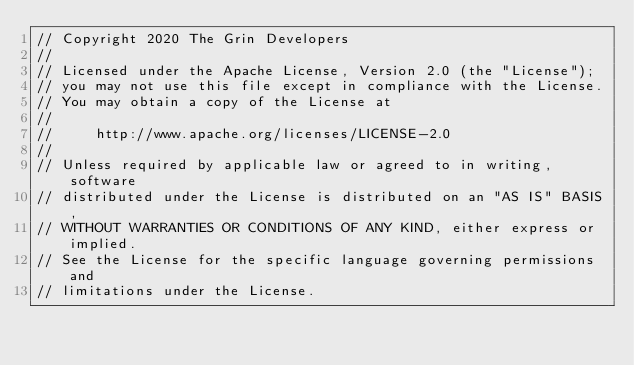<code> <loc_0><loc_0><loc_500><loc_500><_Rust_>// Copyright 2020 The Grin Developers
//
// Licensed under the Apache License, Version 2.0 (the "License");
// you may not use this file except in compliance with the License.
// You may obtain a copy of the License at
//
//     http://www.apache.org/licenses/LICENSE-2.0
//
// Unless required by applicable law or agreed to in writing, software
// distributed under the License is distributed on an "AS IS" BASIS,
// WITHOUT WARRANTIES OR CONDITIONS OF ANY KIND, either express or implied.
// See the License for the specific language governing permissions and
// limitations under the License.
</code> 